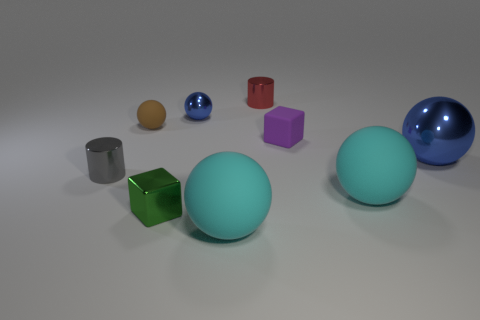Are there any large shiny balls? yes 